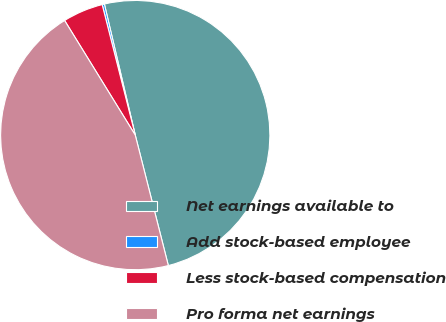Convert chart. <chart><loc_0><loc_0><loc_500><loc_500><pie_chart><fcel>Net earnings available to<fcel>Add stock-based employee<fcel>Less stock-based compensation<fcel>Pro forma net earnings<nl><fcel>49.73%<fcel>0.27%<fcel>4.84%<fcel>45.16%<nl></chart> 